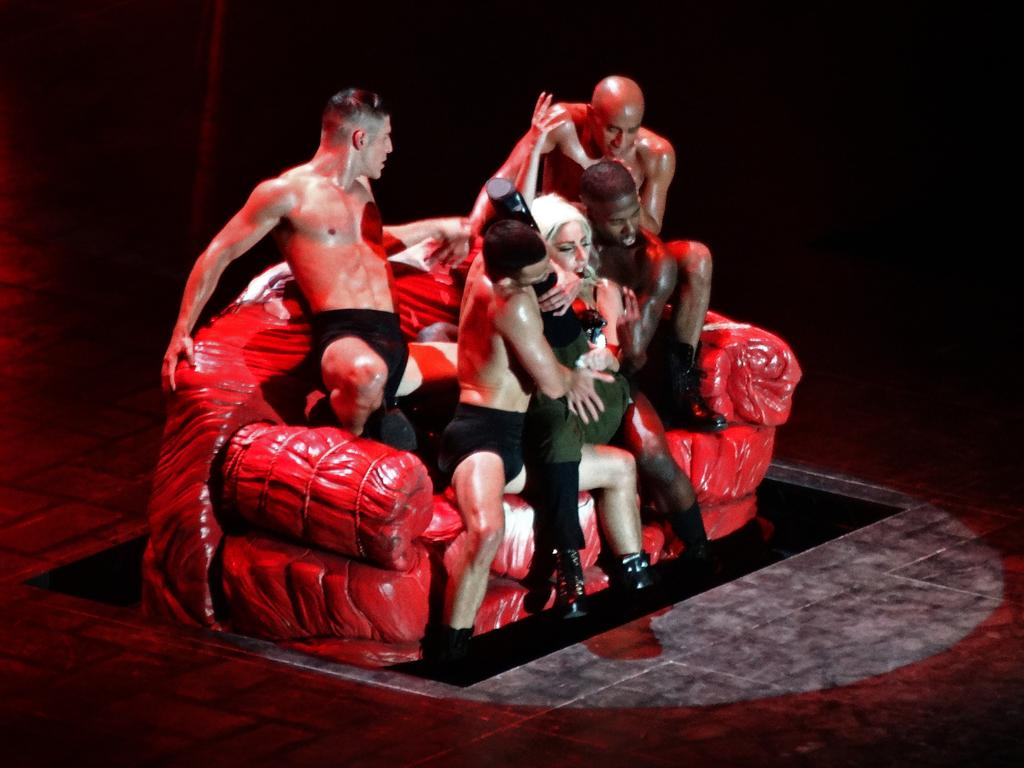How many people are in the image? There are many people in the image. What type of clothing are the people wearing? The people are wearing shorts. Where are the people sitting in the image? The people are sitting on a sofa. What color is the sofa? The sofa is red in color. What can be seen beneath the people in the image? There is a floor visible in the image. What type of footwear are the people wearing? The people are wearing shoes. Can you tell me how many balls are being juggled by the tiger in the image? There is no tiger or balls present in the image. 